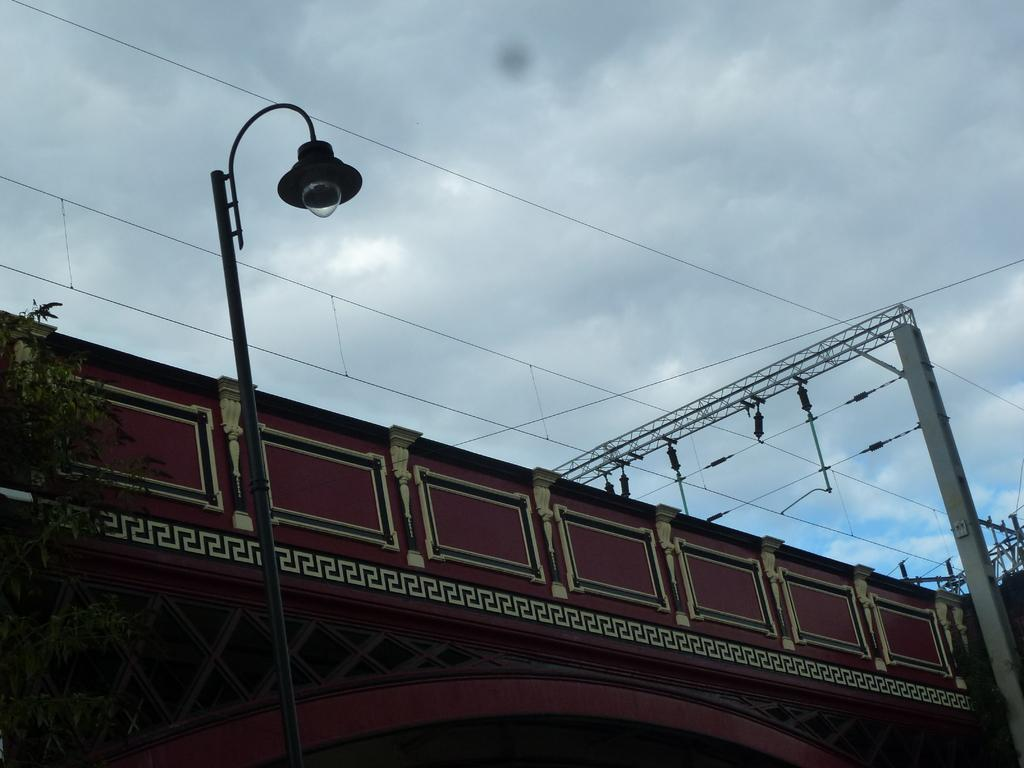What type of structure is visible in the image? There is a building in the image. What other objects can be seen in the image? There are light poles, wires, and a tree in the image. How would you describe the sky in the background? The sky in the background is cloudy. How many friends are sitting on the rock in the image? There is no rock or friends present in the image. 